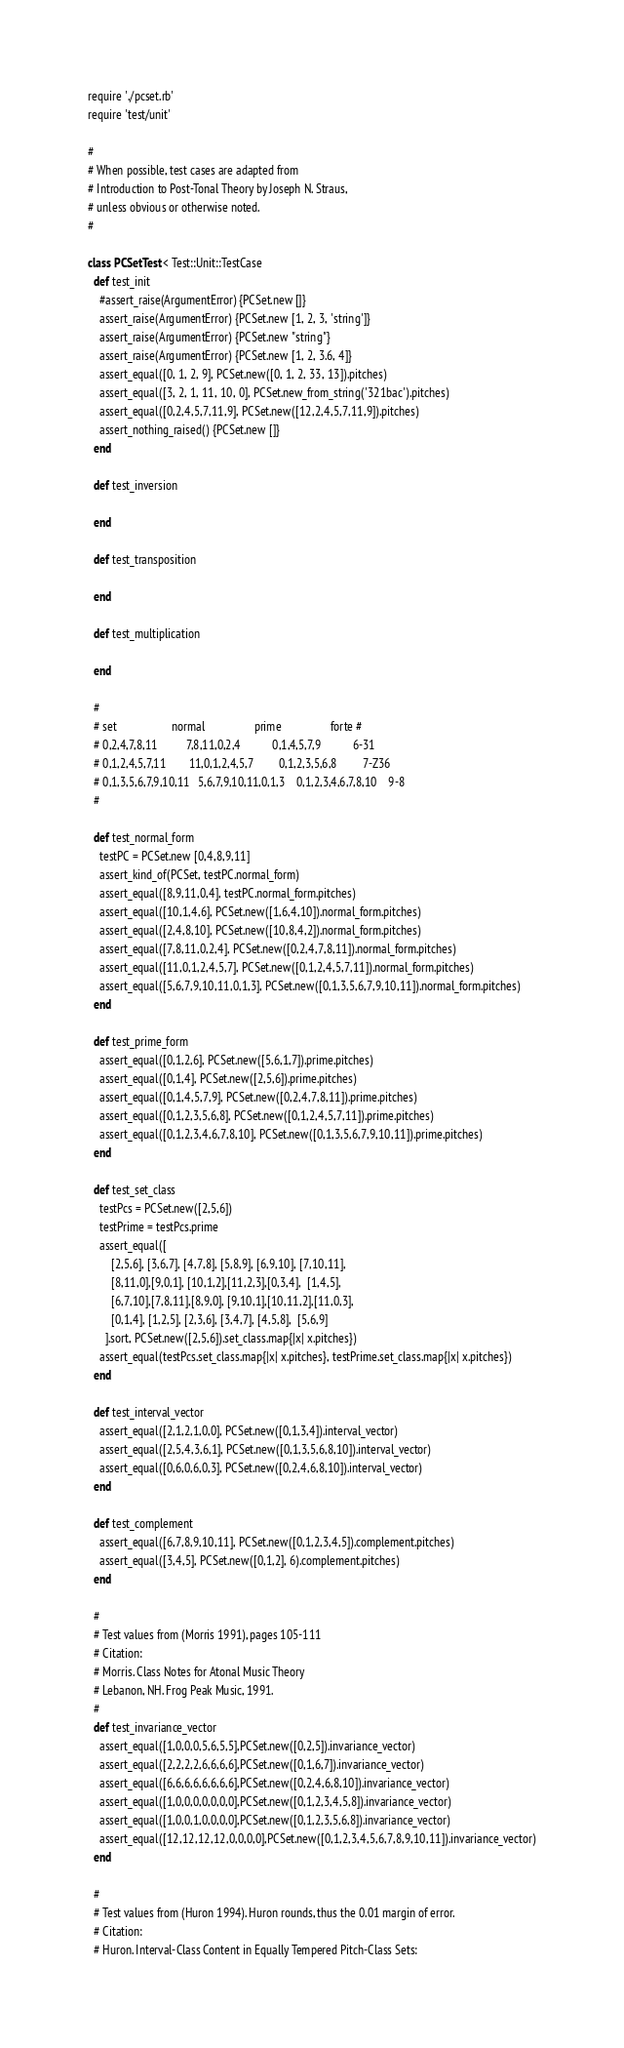Convert code to text. <code><loc_0><loc_0><loc_500><loc_500><_Ruby_>require './pcset.rb'
require 'test/unit'

#
# When possible, test cases are adapted from 
# Introduction to Post-Tonal Theory by Joseph N. Straus,
# unless obvious or otherwise noted.
#

class PCSetTest < Test::Unit::TestCase
  def test_init
    #assert_raise(ArgumentError) {PCSet.new []}
    assert_raise(ArgumentError) {PCSet.new [1, 2, 3, 'string']}
    assert_raise(ArgumentError) {PCSet.new "string"}
    assert_raise(ArgumentError) {PCSet.new [1, 2, 3.6, 4]}
    assert_equal([0, 1, 2, 9], PCSet.new([0, 1, 2, 33, 13]).pitches)
    assert_equal([3, 2, 1, 11, 10, 0], PCSet.new_from_string('321bac').pitches)
    assert_equal([0,2,4,5,7,11,9], PCSet.new([12,2,4,5,7,11,9]).pitches)
    assert_nothing_raised() {PCSet.new []}
  end
  
  def test_inversion
    
  end
  
  def test_transposition
    
  end
  
  def test_multiplication
    
  end
  
  #
  # set                   normal                 prime                 forte #
  # 0,2,4,7,8,11          7,8,11,0,2,4           0,1,4,5,7,9           6-31
  # 0,1,2,4,5,7,11        11,0,1,2,4,5,7         0,1,2,3,5,6,8         7-Z36
  # 0,1,3,5,6,7,9,10,11   5,6,7,9,10,11,0,1,3    0,1,2,3,4,6,7,8,10    9-8
  #
  
  def test_normal_form
    testPC = PCSet.new [0,4,8,9,11]
    assert_kind_of(PCSet, testPC.normal_form)
    assert_equal([8,9,11,0,4], testPC.normal_form.pitches)
    assert_equal([10,1,4,6], PCSet.new([1,6,4,10]).normal_form.pitches)
    assert_equal([2,4,8,10], PCSet.new([10,8,4,2]).normal_form.pitches)
    assert_equal([7,8,11,0,2,4], PCSet.new([0,2,4,7,8,11]).normal_form.pitches)
    assert_equal([11,0,1,2,4,5,7], PCSet.new([0,1,2,4,5,7,11]).normal_form.pitches)
    assert_equal([5,6,7,9,10,11,0,1,3], PCSet.new([0,1,3,5,6,7,9,10,11]).normal_form.pitches)  
  end
  
  def test_prime_form
    assert_equal([0,1,2,6], PCSet.new([5,6,1,7]).prime.pitches)
    assert_equal([0,1,4], PCSet.new([2,5,6]).prime.pitches)
    assert_equal([0,1,4,5,7,9], PCSet.new([0,2,4,7,8,11]).prime.pitches)
    assert_equal([0,1,2,3,5,6,8], PCSet.new([0,1,2,4,5,7,11]).prime.pitches)
    assert_equal([0,1,2,3,4,6,7,8,10], PCSet.new([0,1,3,5,6,7,9,10,11]).prime.pitches)
  end
  
  def test_set_class
    testPcs = PCSet.new([2,5,6])
    testPrime = testPcs.prime
    assert_equal([
        [2,5,6], [3,6,7], [4,7,8], [5,8,9], [6,9,10], [7,10,11],
        [8,11,0],[9,0,1], [10,1,2],[11,2,3],[0,3,4],  [1,4,5],
        [6,7,10],[7,8,11],[8,9,0], [9,10,1],[10,11,2],[11,0,3],
        [0,1,4], [1,2,5], [2,3,6], [3,4,7], [4,5,8],  [5,6,9]
      ].sort, PCSet.new([2,5,6]).set_class.map{|x| x.pitches})
    assert_equal(testPcs.set_class.map{|x| x.pitches}, testPrime.set_class.map{|x| x.pitches})
  end
  
  def test_interval_vector
    assert_equal([2,1,2,1,0,0], PCSet.new([0,1,3,4]).interval_vector)
    assert_equal([2,5,4,3,6,1], PCSet.new([0,1,3,5,6,8,10]).interval_vector)
    assert_equal([0,6,0,6,0,3], PCSet.new([0,2,4,6,8,10]).interval_vector)
  end
  
  def test_complement
    assert_equal([6,7,8,9,10,11], PCSet.new([0,1,2,3,4,5]).complement.pitches)
    assert_equal([3,4,5], PCSet.new([0,1,2], 6).complement.pitches)
  end
  
  #
  # Test values from (Morris 1991), pages 105-111
  # Citation:
  # Morris. Class Notes for Atonal Music Theory
  # Lebanon, NH. Frog Peak Music, 1991.
  #
  def test_invariance_vector
    assert_equal([1,0,0,0,5,6,5,5],PCSet.new([0,2,5]).invariance_vector)
    assert_equal([2,2,2,2,6,6,6,6],PCSet.new([0,1,6,7]).invariance_vector)
    assert_equal([6,6,6,6,6,6,6,6],PCSet.new([0,2,4,6,8,10]).invariance_vector)
    assert_equal([1,0,0,0,0,0,0,0],PCSet.new([0,1,2,3,4,5,8]).invariance_vector)
    assert_equal([1,0,0,1,0,0,0,0],PCSet.new([0,1,2,3,5,6,8]).invariance_vector)
    assert_equal([12,12,12,12,0,0,0,0],PCSet.new([0,1,2,3,4,5,6,7,8,9,10,11]).invariance_vector)
  end
  
  #
  # Test values from (Huron 1994). Huron rounds, thus the 0.01 margin of error.
  # Citation:
  # Huron. Interval-Class Content in Equally Tempered Pitch-Class Sets: </code> 